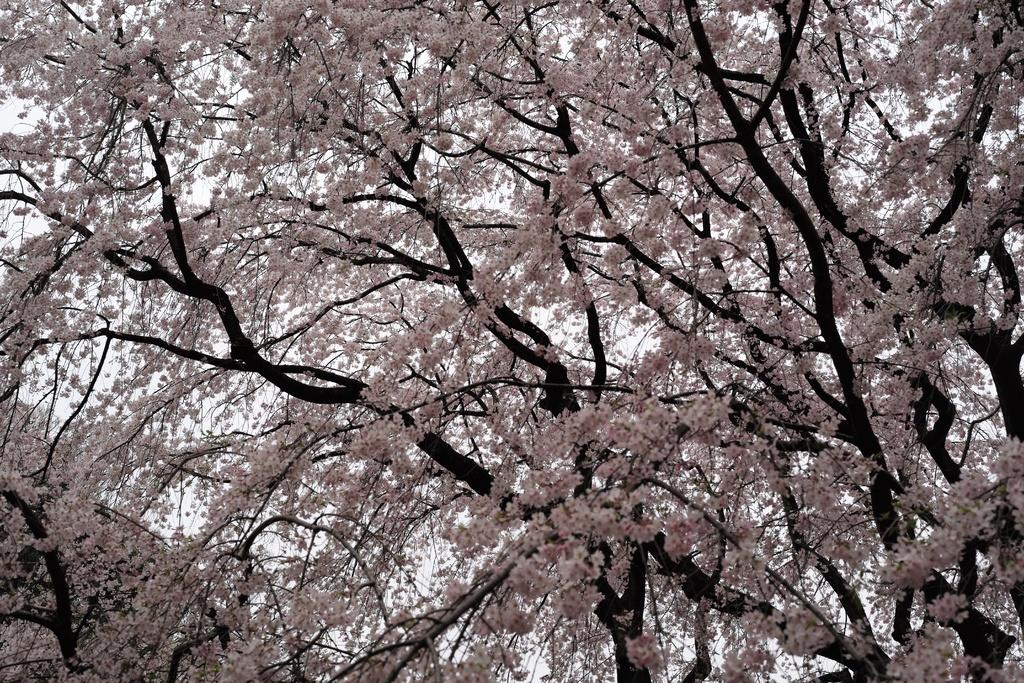What type of natural element is present in the image? There is a tree in the image. What type of musical instruments can be seen on the tray in the image? There is no tray or musical instruments present in the image; it only features a tree. 